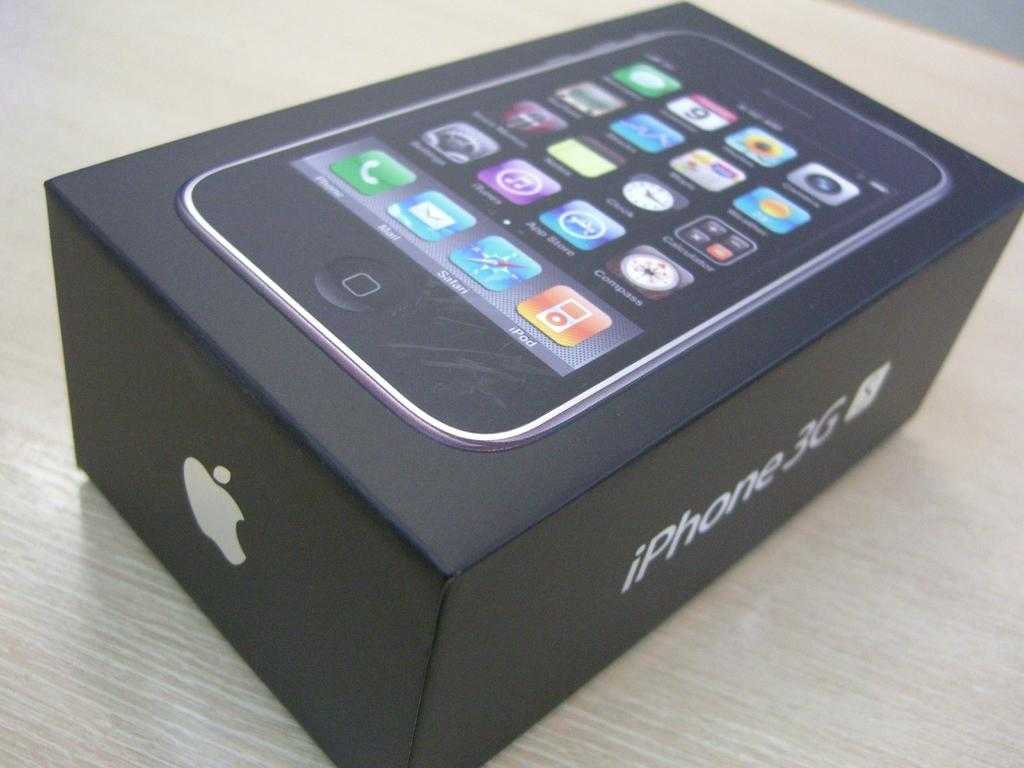<image>
Write a terse but informative summary of the picture. A black iPhone 3G apple phone box on a counter top 